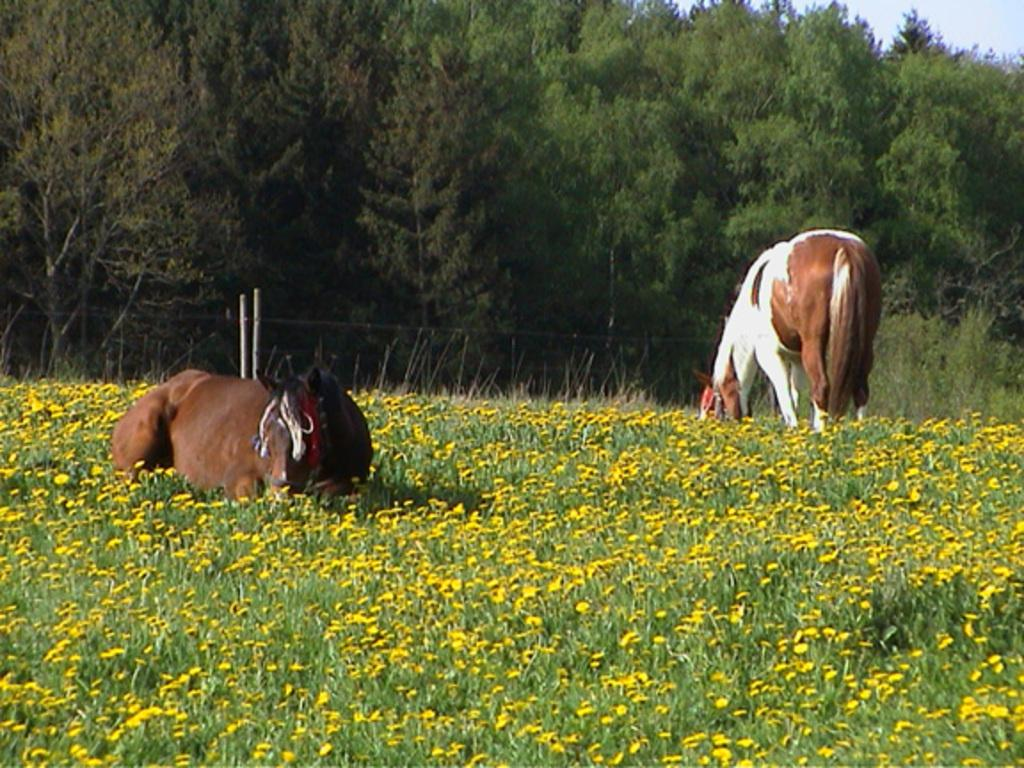How many horses are in the image? There are 2 horses in the image. What is the position of the horses in the image? The horses are standing on the ground. What type of vegetation can be seen in the image? There are flowers on a plant in the image, and trees are visible in the background. Where is the plant located in the image? The plant is on the ground. What type of amusement can be seen in the image? There is no amusement present in the image; it features 2 horses standing on the ground, flowers on a plant, and trees in the background. Can you tell me where the scissors are located in the image? There are no scissors present in the image. 